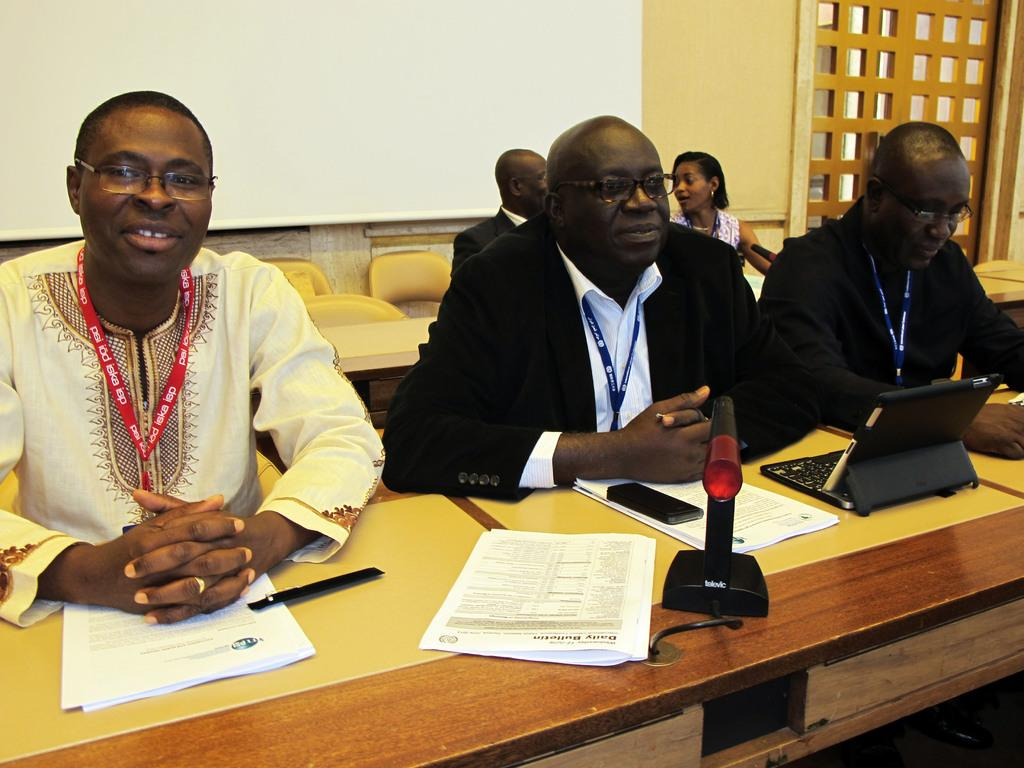Who or what can be seen in the image? There are people in the image. What type of furniture is present in the image? There are chairs and tables in the image. What is the color of the wall in the image? There is a white color wall in the image. What items can be found on the tables? There are papers, a mobile phone, and a laptop on the tables. What type of haircut is being given in the image? There is no haircut being given in the image; it does not depict a hair salon or barber shop. 